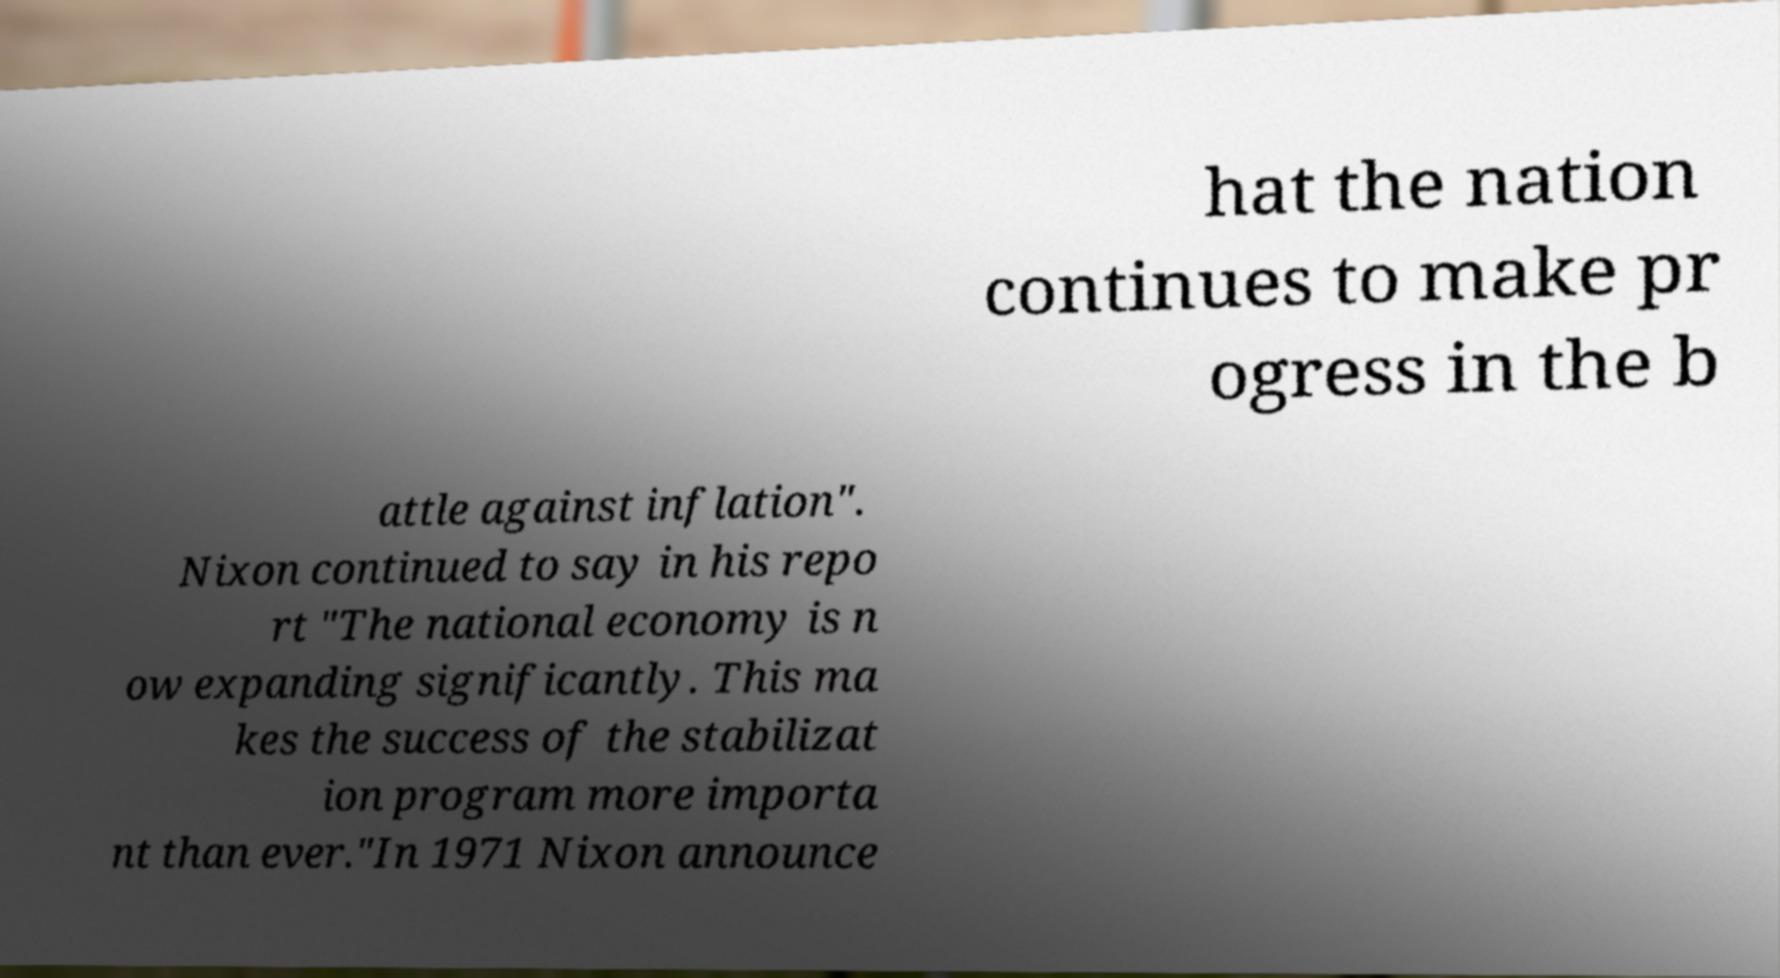Please read and relay the text visible in this image. What does it say? hat the nation continues to make pr ogress in the b attle against inflation". Nixon continued to say in his repo rt "The national economy is n ow expanding significantly. This ma kes the success of the stabilizat ion program more importa nt than ever."In 1971 Nixon announce 